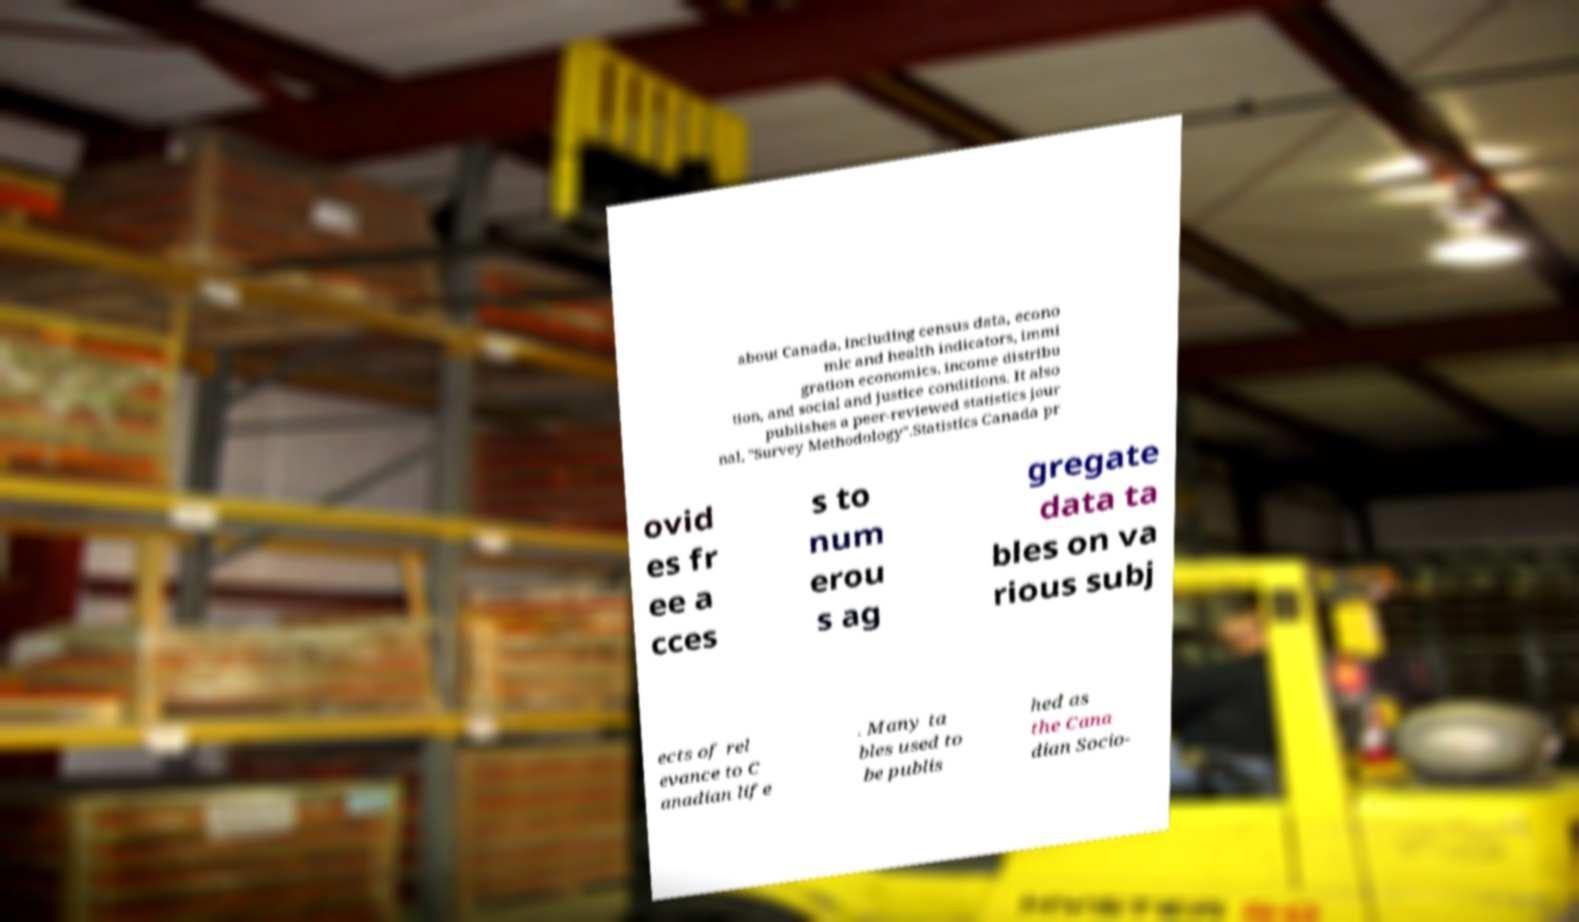Can you read and provide the text displayed in the image?This photo seems to have some interesting text. Can you extract and type it out for me? about Canada, including census data, econo mic and health indicators, immi gration economics, income distribu tion, and social and justice conditions. It also publishes a peer-reviewed statistics jour nal, "Survey Methodology".Statistics Canada pr ovid es fr ee a cces s to num erou s ag gregate data ta bles on va rious subj ects of rel evance to C anadian life . Many ta bles used to be publis hed as the Cana dian Socio- 